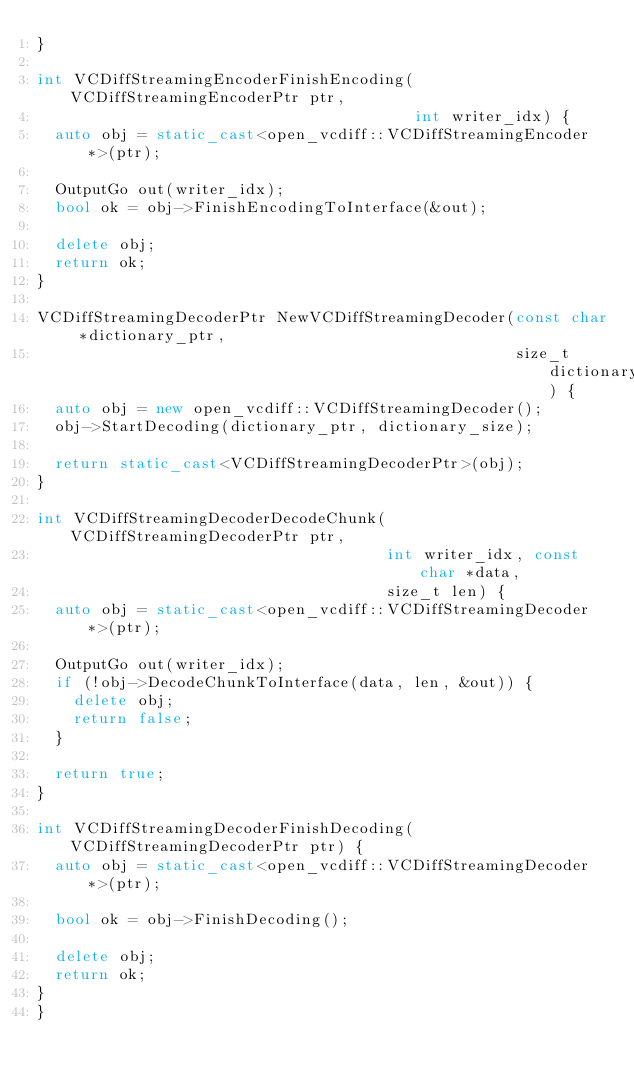Convert code to text. <code><loc_0><loc_0><loc_500><loc_500><_C++_>}

int VCDiffStreamingEncoderFinishEncoding(VCDiffStreamingEncoderPtr ptr,
                                         int writer_idx) {
	auto obj = static_cast<open_vcdiff::VCDiffStreamingEncoder *>(ptr);

	OutputGo out(writer_idx);
	bool ok = obj->FinishEncodingToInterface(&out);

	delete obj;
	return ok;
}

VCDiffStreamingDecoderPtr NewVCDiffStreamingDecoder(const char *dictionary_ptr,
                                                    size_t dictionary_size) {
	auto obj = new open_vcdiff::VCDiffStreamingDecoder();
	obj->StartDecoding(dictionary_ptr, dictionary_size);

	return static_cast<VCDiffStreamingDecoderPtr>(obj);
}

int VCDiffStreamingDecoderDecodeChunk(VCDiffStreamingDecoderPtr ptr,
                                      int writer_idx, const char *data,
                                      size_t len) {
	auto obj = static_cast<open_vcdiff::VCDiffStreamingDecoder *>(ptr);

	OutputGo out(writer_idx);
	if (!obj->DecodeChunkToInterface(data, len, &out)) {
		delete obj;
		return false;
	}

	return true;
}

int VCDiffStreamingDecoderFinishDecoding(VCDiffStreamingDecoderPtr ptr) {
	auto obj = static_cast<open_vcdiff::VCDiffStreamingDecoder *>(ptr);

	bool ok = obj->FinishDecoding();

	delete obj;
	return ok;
}
}</code> 